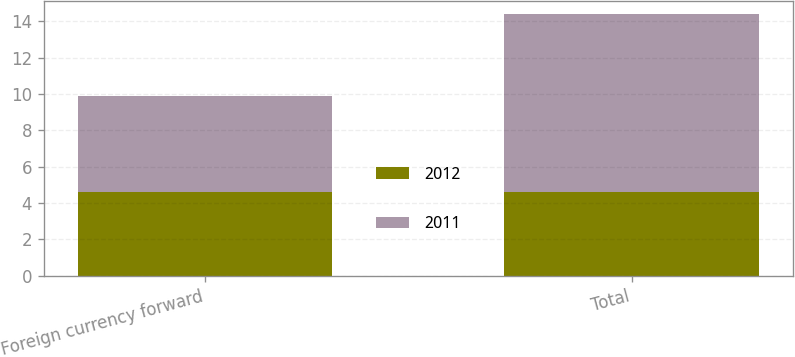Convert chart. <chart><loc_0><loc_0><loc_500><loc_500><stacked_bar_chart><ecel><fcel>Foreign currency forward<fcel>Total<nl><fcel>2012<fcel>4.6<fcel>4.6<nl><fcel>2011<fcel>5.3<fcel>9.8<nl></chart> 